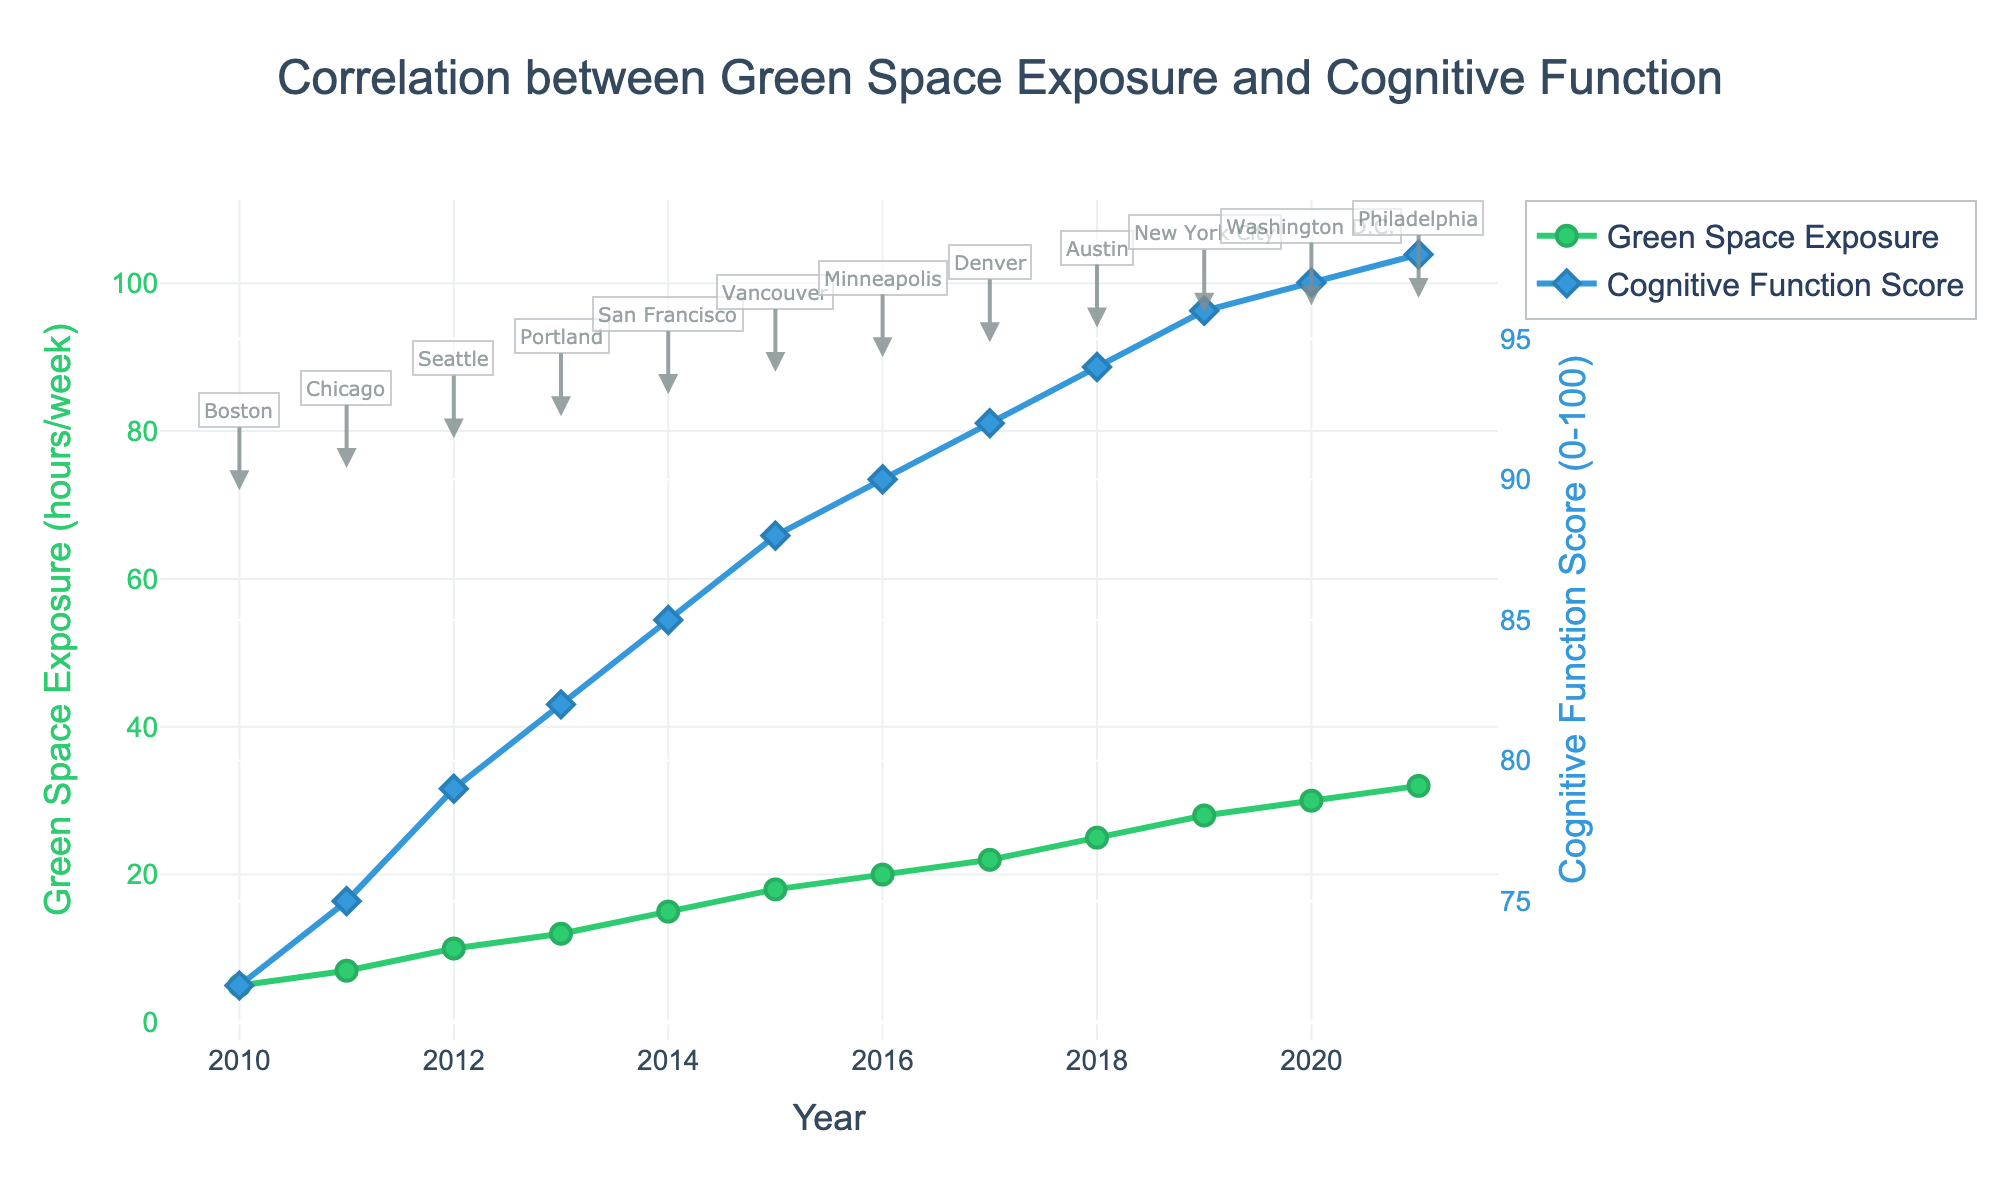What is the general trend in Green Space Exposure over the years? The figure shows that the Green Space Exposure (hours/week) increases consistently from 2010 to 2021.
Answer: Increasing trend How does the Cognitive Function Score change from 2010 to 2021? The figure illustrates that the Cognitive Function Score steadily increases over the years, starting from 72 in 2010 and reaching 98 in 2021.
Answer: Steadily increases Which city corresponds to the highest Cognitive Function Score, and what is that score? The highest Cognitive Function Score is in Philadelphia, corresponding to a score of 98 in 2021.
Answer: Philadelphia, 98 Compare the Green Space Exposure between Boston (2010) and Washington D.C. (2020). In the figure, Boston (2010) has a Green Space Exposure of 5 hours/week, while Washington D.C. (2020) has 30 hours/week. Hence, Washington D.C.'s Green Space Exposure is significantly higher.
Answer: Washington D.C. > Boston Visualize and explain the relationship between the Green Space Exposure and Cognitive Function Score. The graph shows that as Green Space Exposure increases, the Cognitive Function Score also increases. This positive correlation is evident as both lines trend upwards together.
Answer: Positive correlation Calculate the average Cognitive Function Score for the years 2010, 2015, and 2020. The Cognitive Function Scores for these years are 72 (2010), 88 (2015), and 97 (2020). Average = (72 + 88 + 97) / 3 = 85.67.
Answer: 85.67 Identify the year in which the sharpest increase in Green Space Exposure occurs. The sharpest increase in Green Space Exposure appears between 2018 (25 hours) and 2019 (28 hours). Hence, 2019 marks the year of sharpest increase.
Answer: 2019 What conclusions can be made about the impact of environmental factors on cognitive development based on this data? The consistent increase in Cognitive Function Score with the increase in Green Space Exposure suggests that environmental factors like exposure to green spaces positively influence cognitive development.
Answer: Positive impact on cognitive development 